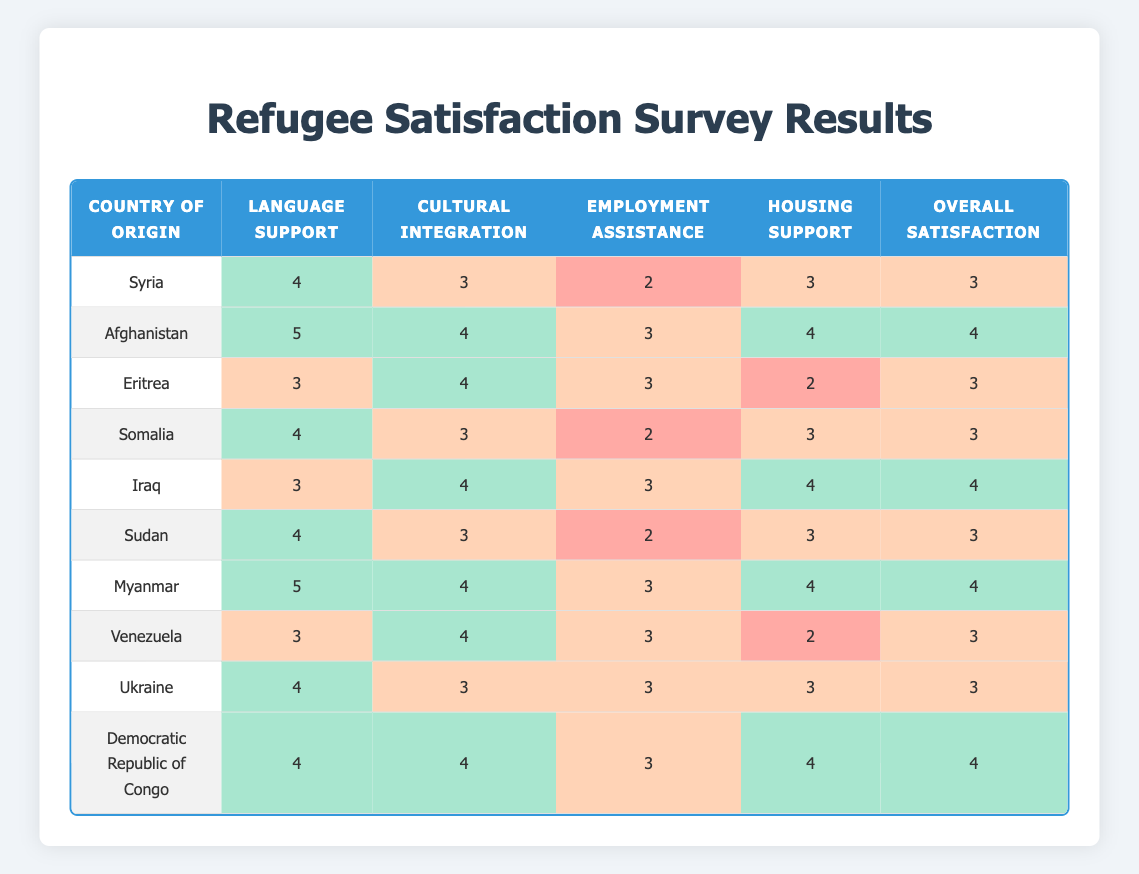What is the overall satisfaction rating for refugees from Afghanistan? Looking at the row for Afghanistan, the Overall Satisfaction rating is directly listed as 4.
Answer: 4 Which country of origin has the highest satisfaction in Language Support? By examining the Language Support column, both Afghanistan and Myanmar have a satisfaction rating of 5, which is the highest among all entries.
Answer: Afghanistan and Myanmar What is the average Cultural Integration Satisfaction rating for refugees from countries in Africa (Eritrea, Somalia, Iraq, Sudan, Democratic Republic of Congo)? The Cultural Integration Satisfaction ratings for these countries are 4, 3, 4, 3, and 4 respectively. To find the average, we add these ratings (4 + 3 + 4 + 3 + 4 = 18) and divide by the number of countries (5). Therefore, the average is 18/5 = 3.6.
Answer: 3.6 Is the Employment Assistance Satisfaction rating for Syrian refugees higher than that for Venezuelan refugees? The Employment Assistance Satisfaction rating for Syria is 2 and for Venezuela is 3. Since 2 is less than 3, the statement is false.
Answer: No What is the difference between the highest and lowest Housing Support ratings among the listed countries? After reviewing the Housing Support ratings, the highest is 4 (Afghanistan, Iraq, Myanmar, Democratic Republic of Congo) and the lowest is 2 (Eritrea, Venezuela). The difference is calculated by subtracting the lowest from the highest: 4 - 2 = 2.
Answer: 2 How many countries have a Cultural Integration Satisfaction rating of 4 or higher? From the table, we see that the countries with a Cultural Integration Satisfaction rating of 4 or higher are Afghanistan, Eritrea, Myanmar, Iraq, and Democratic Republic of Congo. This gives us a total of 5 countries.
Answer: 5 What is the overall trend in satisfaction for language support compared to cultural integration across all countries? By comparing all entries, we find that seven countries have a Language Support rating of 4 or higher (Syria, Afghanistan, Somalia, Myanmar, Iraq, Sudan, Democratic Republic of Congo) while only four countries report a Cultural Integration Satisfaction of 4 or higher (Afghanistan, Eritrea, Myanmar, Iraq, and Democratic Republic of Congo). This indicates that more countries are satisfied with Language Support compared to Cultural Integration.
Answer: Language support satisfaction is higher than cultural integration How many countries have an Employment Assistance Satisfaction rating of 3? The countries with an Employment Assistance Satisfaction rating of 3 are Afghanistan, Eritrea, Iraq, Myanmar, Ukraine, and Democratic Republic of Congo. Counting these entries, there are 6 countries.
Answer: 6 